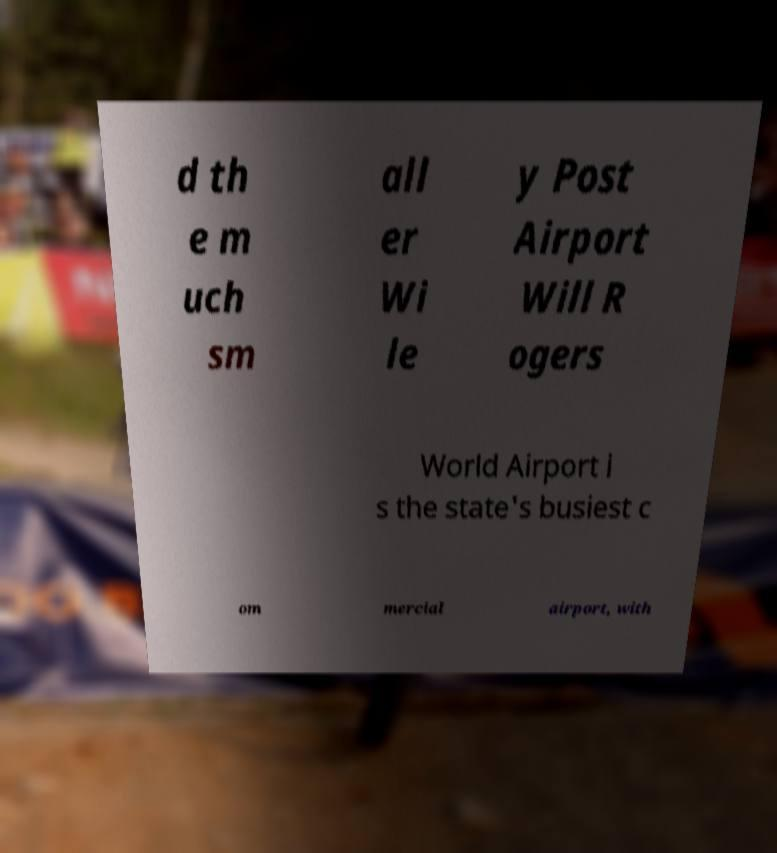There's text embedded in this image that I need extracted. Can you transcribe it verbatim? d th e m uch sm all er Wi le y Post Airport Will R ogers World Airport i s the state's busiest c om mercial airport, with 